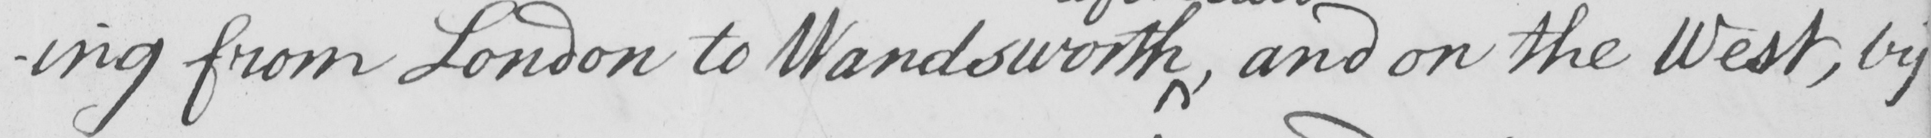What does this handwritten line say? -ing from London to Wandsworth  , and on the West , by 